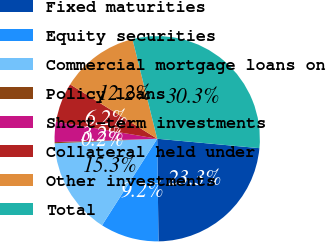Convert chart. <chart><loc_0><loc_0><loc_500><loc_500><pie_chart><fcel>Fixed maturities<fcel>Equity securities<fcel>Commercial mortgage loans on<fcel>Policy loans<fcel>Short-term investments<fcel>Collateral held under<fcel>Other investments<fcel>Total<nl><fcel>23.34%<fcel>9.23%<fcel>15.26%<fcel>0.18%<fcel>3.2%<fcel>6.21%<fcel>12.24%<fcel>30.34%<nl></chart> 